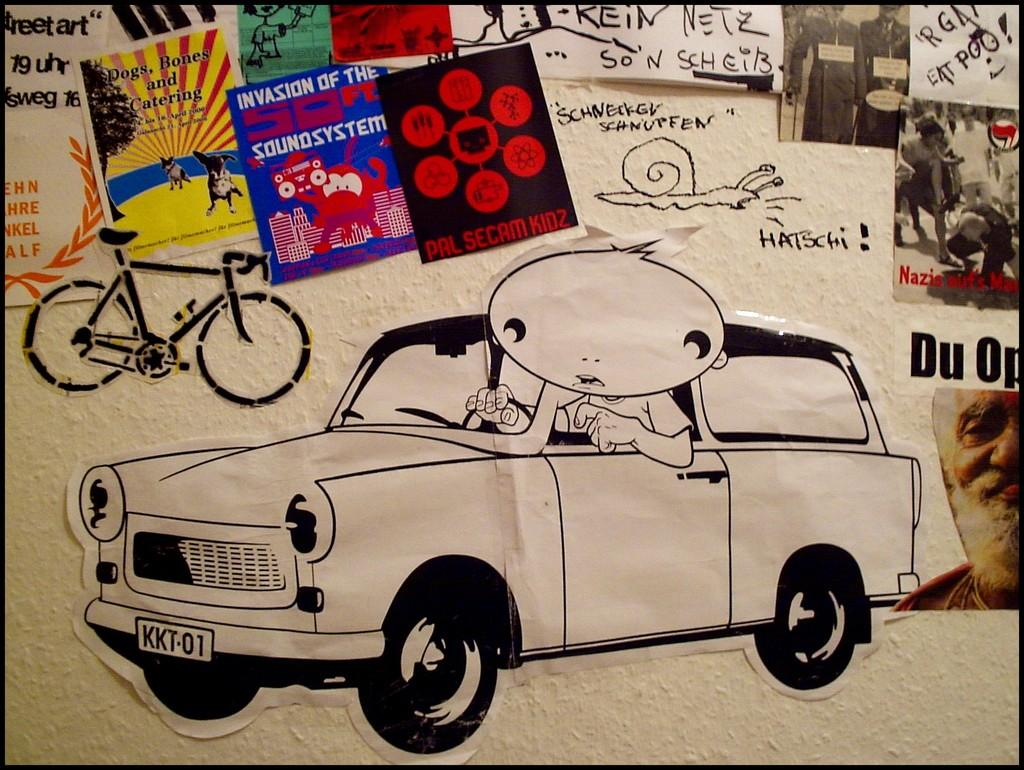What is attached to the wall in the image? There are posts on the wall in the image. What can be seen on the posts? The posts have pictures on them. What is written on the posts? There is text written on the posts. What type of thread is used to hang the canvas in the image? There is no canvas present in the image, and therefore no thread is used to hang it. 